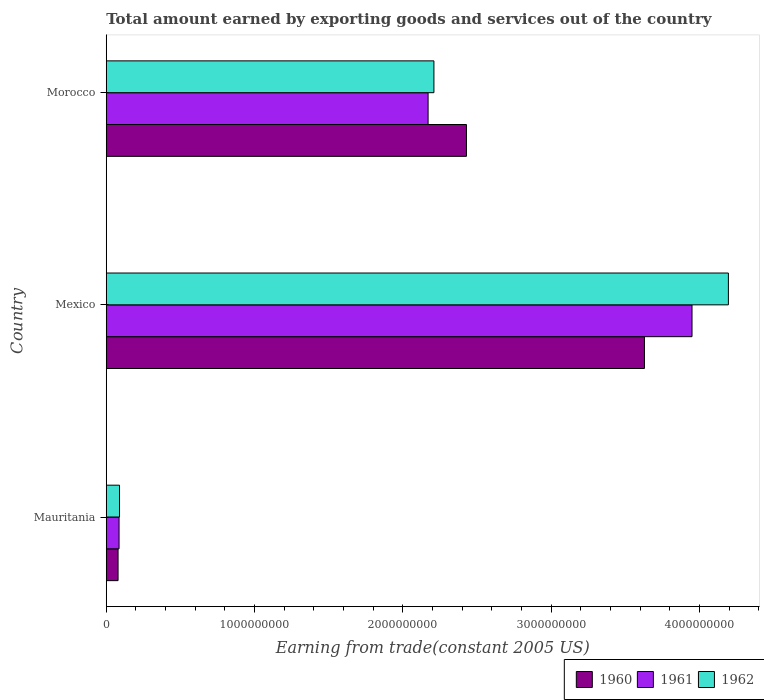How many different coloured bars are there?
Provide a short and direct response. 3. How many bars are there on the 1st tick from the top?
Provide a short and direct response. 3. How many bars are there on the 1st tick from the bottom?
Your answer should be compact. 3. What is the label of the 3rd group of bars from the top?
Keep it short and to the point. Mauritania. What is the total amount earned by exporting goods and services in 1961 in Mauritania?
Offer a terse response. 8.64e+07. Across all countries, what is the maximum total amount earned by exporting goods and services in 1961?
Provide a succinct answer. 3.95e+09. Across all countries, what is the minimum total amount earned by exporting goods and services in 1960?
Make the answer very short. 7.97e+07. In which country was the total amount earned by exporting goods and services in 1961 minimum?
Your answer should be compact. Mauritania. What is the total total amount earned by exporting goods and services in 1962 in the graph?
Offer a very short reply. 6.49e+09. What is the difference between the total amount earned by exporting goods and services in 1960 in Mauritania and that in Morocco?
Keep it short and to the point. -2.35e+09. What is the difference between the total amount earned by exporting goods and services in 1962 in Mauritania and the total amount earned by exporting goods and services in 1960 in Morocco?
Make the answer very short. -2.34e+09. What is the average total amount earned by exporting goods and services in 1961 per country?
Your response must be concise. 2.07e+09. What is the difference between the total amount earned by exporting goods and services in 1961 and total amount earned by exporting goods and services in 1962 in Mexico?
Your answer should be very brief. -2.45e+08. In how many countries, is the total amount earned by exporting goods and services in 1960 greater than 3600000000 US$?
Your answer should be very brief. 1. What is the ratio of the total amount earned by exporting goods and services in 1961 in Mauritania to that in Morocco?
Ensure brevity in your answer.  0.04. Is the total amount earned by exporting goods and services in 1960 in Mexico less than that in Morocco?
Keep it short and to the point. No. What is the difference between the highest and the second highest total amount earned by exporting goods and services in 1960?
Your answer should be compact. 1.20e+09. What is the difference between the highest and the lowest total amount earned by exporting goods and services in 1962?
Make the answer very short. 4.10e+09. What does the 3rd bar from the bottom in Morocco represents?
Make the answer very short. 1962. Is it the case that in every country, the sum of the total amount earned by exporting goods and services in 1961 and total amount earned by exporting goods and services in 1960 is greater than the total amount earned by exporting goods and services in 1962?
Make the answer very short. Yes. How many countries are there in the graph?
Offer a very short reply. 3. Does the graph contain any zero values?
Give a very brief answer. No. Does the graph contain grids?
Provide a succinct answer. No. Where does the legend appear in the graph?
Provide a short and direct response. Bottom right. How are the legend labels stacked?
Your response must be concise. Horizontal. What is the title of the graph?
Offer a very short reply. Total amount earned by exporting goods and services out of the country. Does "2015" appear as one of the legend labels in the graph?
Offer a very short reply. No. What is the label or title of the X-axis?
Offer a terse response. Earning from trade(constant 2005 US). What is the Earning from trade(constant 2005 US) of 1960 in Mauritania?
Offer a terse response. 7.97e+07. What is the Earning from trade(constant 2005 US) in 1961 in Mauritania?
Your response must be concise. 8.64e+07. What is the Earning from trade(constant 2005 US) of 1962 in Mauritania?
Provide a short and direct response. 8.95e+07. What is the Earning from trade(constant 2005 US) of 1960 in Mexico?
Provide a succinct answer. 3.63e+09. What is the Earning from trade(constant 2005 US) in 1961 in Mexico?
Offer a very short reply. 3.95e+09. What is the Earning from trade(constant 2005 US) of 1962 in Mexico?
Your answer should be very brief. 4.19e+09. What is the Earning from trade(constant 2005 US) of 1960 in Morocco?
Your answer should be very brief. 2.43e+09. What is the Earning from trade(constant 2005 US) in 1961 in Morocco?
Your response must be concise. 2.17e+09. What is the Earning from trade(constant 2005 US) of 1962 in Morocco?
Ensure brevity in your answer.  2.21e+09. Across all countries, what is the maximum Earning from trade(constant 2005 US) of 1960?
Provide a short and direct response. 3.63e+09. Across all countries, what is the maximum Earning from trade(constant 2005 US) in 1961?
Your response must be concise. 3.95e+09. Across all countries, what is the maximum Earning from trade(constant 2005 US) in 1962?
Offer a very short reply. 4.19e+09. Across all countries, what is the minimum Earning from trade(constant 2005 US) in 1960?
Make the answer very short. 7.97e+07. Across all countries, what is the minimum Earning from trade(constant 2005 US) of 1961?
Make the answer very short. 8.64e+07. Across all countries, what is the minimum Earning from trade(constant 2005 US) of 1962?
Provide a short and direct response. 8.95e+07. What is the total Earning from trade(constant 2005 US) of 1960 in the graph?
Provide a succinct answer. 6.14e+09. What is the total Earning from trade(constant 2005 US) of 1961 in the graph?
Your response must be concise. 6.21e+09. What is the total Earning from trade(constant 2005 US) in 1962 in the graph?
Offer a very short reply. 6.49e+09. What is the difference between the Earning from trade(constant 2005 US) in 1960 in Mauritania and that in Mexico?
Your answer should be compact. -3.55e+09. What is the difference between the Earning from trade(constant 2005 US) in 1961 in Mauritania and that in Mexico?
Provide a succinct answer. -3.86e+09. What is the difference between the Earning from trade(constant 2005 US) in 1962 in Mauritania and that in Mexico?
Give a very brief answer. -4.10e+09. What is the difference between the Earning from trade(constant 2005 US) of 1960 in Mauritania and that in Morocco?
Provide a short and direct response. -2.35e+09. What is the difference between the Earning from trade(constant 2005 US) of 1961 in Mauritania and that in Morocco?
Provide a succinct answer. -2.08e+09. What is the difference between the Earning from trade(constant 2005 US) in 1962 in Mauritania and that in Morocco?
Your answer should be very brief. -2.12e+09. What is the difference between the Earning from trade(constant 2005 US) of 1960 in Mexico and that in Morocco?
Make the answer very short. 1.20e+09. What is the difference between the Earning from trade(constant 2005 US) in 1961 in Mexico and that in Morocco?
Offer a very short reply. 1.78e+09. What is the difference between the Earning from trade(constant 2005 US) in 1962 in Mexico and that in Morocco?
Your response must be concise. 1.99e+09. What is the difference between the Earning from trade(constant 2005 US) of 1960 in Mauritania and the Earning from trade(constant 2005 US) of 1961 in Mexico?
Offer a very short reply. -3.87e+09. What is the difference between the Earning from trade(constant 2005 US) of 1960 in Mauritania and the Earning from trade(constant 2005 US) of 1962 in Mexico?
Provide a short and direct response. -4.11e+09. What is the difference between the Earning from trade(constant 2005 US) in 1961 in Mauritania and the Earning from trade(constant 2005 US) in 1962 in Mexico?
Your response must be concise. -4.11e+09. What is the difference between the Earning from trade(constant 2005 US) in 1960 in Mauritania and the Earning from trade(constant 2005 US) in 1961 in Morocco?
Make the answer very short. -2.09e+09. What is the difference between the Earning from trade(constant 2005 US) in 1960 in Mauritania and the Earning from trade(constant 2005 US) in 1962 in Morocco?
Your answer should be very brief. -2.13e+09. What is the difference between the Earning from trade(constant 2005 US) of 1961 in Mauritania and the Earning from trade(constant 2005 US) of 1962 in Morocco?
Offer a terse response. -2.12e+09. What is the difference between the Earning from trade(constant 2005 US) of 1960 in Mexico and the Earning from trade(constant 2005 US) of 1961 in Morocco?
Ensure brevity in your answer.  1.46e+09. What is the difference between the Earning from trade(constant 2005 US) of 1960 in Mexico and the Earning from trade(constant 2005 US) of 1962 in Morocco?
Your answer should be very brief. 1.42e+09. What is the difference between the Earning from trade(constant 2005 US) in 1961 in Mexico and the Earning from trade(constant 2005 US) in 1962 in Morocco?
Your answer should be compact. 1.74e+09. What is the average Earning from trade(constant 2005 US) of 1960 per country?
Provide a short and direct response. 2.05e+09. What is the average Earning from trade(constant 2005 US) of 1961 per country?
Make the answer very short. 2.07e+09. What is the average Earning from trade(constant 2005 US) in 1962 per country?
Ensure brevity in your answer.  2.16e+09. What is the difference between the Earning from trade(constant 2005 US) of 1960 and Earning from trade(constant 2005 US) of 1961 in Mauritania?
Give a very brief answer. -6.74e+06. What is the difference between the Earning from trade(constant 2005 US) of 1960 and Earning from trade(constant 2005 US) of 1962 in Mauritania?
Make the answer very short. -9.81e+06. What is the difference between the Earning from trade(constant 2005 US) of 1961 and Earning from trade(constant 2005 US) of 1962 in Mauritania?
Offer a terse response. -3.07e+06. What is the difference between the Earning from trade(constant 2005 US) of 1960 and Earning from trade(constant 2005 US) of 1961 in Mexico?
Offer a very short reply. -3.21e+08. What is the difference between the Earning from trade(constant 2005 US) of 1960 and Earning from trade(constant 2005 US) of 1962 in Mexico?
Your response must be concise. -5.66e+08. What is the difference between the Earning from trade(constant 2005 US) in 1961 and Earning from trade(constant 2005 US) in 1962 in Mexico?
Ensure brevity in your answer.  -2.45e+08. What is the difference between the Earning from trade(constant 2005 US) in 1960 and Earning from trade(constant 2005 US) in 1961 in Morocco?
Offer a very short reply. 2.59e+08. What is the difference between the Earning from trade(constant 2005 US) of 1960 and Earning from trade(constant 2005 US) of 1962 in Morocco?
Ensure brevity in your answer.  2.19e+08. What is the difference between the Earning from trade(constant 2005 US) in 1961 and Earning from trade(constant 2005 US) in 1962 in Morocco?
Your answer should be compact. -3.93e+07. What is the ratio of the Earning from trade(constant 2005 US) in 1960 in Mauritania to that in Mexico?
Offer a terse response. 0.02. What is the ratio of the Earning from trade(constant 2005 US) in 1961 in Mauritania to that in Mexico?
Your answer should be very brief. 0.02. What is the ratio of the Earning from trade(constant 2005 US) of 1962 in Mauritania to that in Mexico?
Your response must be concise. 0.02. What is the ratio of the Earning from trade(constant 2005 US) of 1960 in Mauritania to that in Morocco?
Your response must be concise. 0.03. What is the ratio of the Earning from trade(constant 2005 US) in 1961 in Mauritania to that in Morocco?
Offer a very short reply. 0.04. What is the ratio of the Earning from trade(constant 2005 US) in 1962 in Mauritania to that in Morocco?
Offer a very short reply. 0.04. What is the ratio of the Earning from trade(constant 2005 US) of 1960 in Mexico to that in Morocco?
Provide a succinct answer. 1.49. What is the ratio of the Earning from trade(constant 2005 US) of 1961 in Mexico to that in Morocco?
Give a very brief answer. 1.82. What is the ratio of the Earning from trade(constant 2005 US) of 1962 in Mexico to that in Morocco?
Your response must be concise. 1.9. What is the difference between the highest and the second highest Earning from trade(constant 2005 US) of 1960?
Offer a very short reply. 1.20e+09. What is the difference between the highest and the second highest Earning from trade(constant 2005 US) in 1961?
Offer a very short reply. 1.78e+09. What is the difference between the highest and the second highest Earning from trade(constant 2005 US) of 1962?
Your answer should be compact. 1.99e+09. What is the difference between the highest and the lowest Earning from trade(constant 2005 US) in 1960?
Provide a short and direct response. 3.55e+09. What is the difference between the highest and the lowest Earning from trade(constant 2005 US) in 1961?
Offer a terse response. 3.86e+09. What is the difference between the highest and the lowest Earning from trade(constant 2005 US) in 1962?
Your answer should be compact. 4.10e+09. 